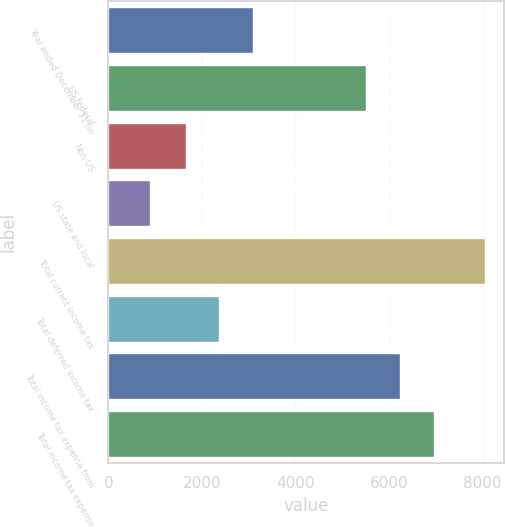Convert chart. <chart><loc_0><loc_0><loc_500><loc_500><bar_chart><fcel>Year ended December 31 (in<fcel>US federal<fcel>Non-US<fcel>US state and local<fcel>Total current income tax<fcel>Total deferred income tax<fcel>Total income tax expense from<fcel>Total income tax expense<nl><fcel>3089.6<fcel>5512<fcel>1656<fcel>879<fcel>8047<fcel>2372.8<fcel>6237<fcel>6953.8<nl></chart> 